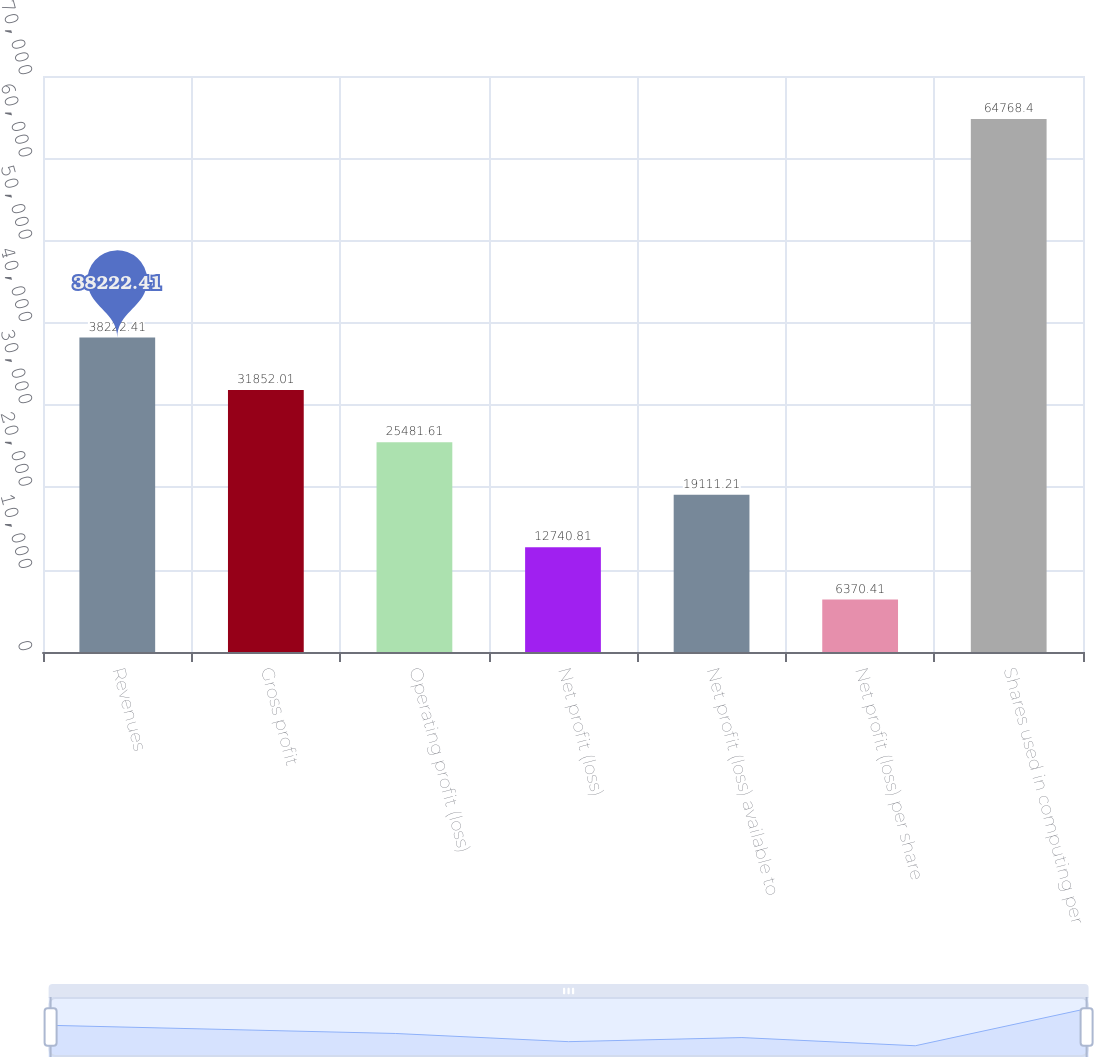<chart> <loc_0><loc_0><loc_500><loc_500><bar_chart><fcel>Revenues<fcel>Gross profit<fcel>Operating profit (loss)<fcel>Net profit (loss)<fcel>Net profit (loss) available to<fcel>Net profit (loss) per share<fcel>Shares used in computing per<nl><fcel>38222.4<fcel>31852<fcel>25481.6<fcel>12740.8<fcel>19111.2<fcel>6370.41<fcel>64768.4<nl></chart> 